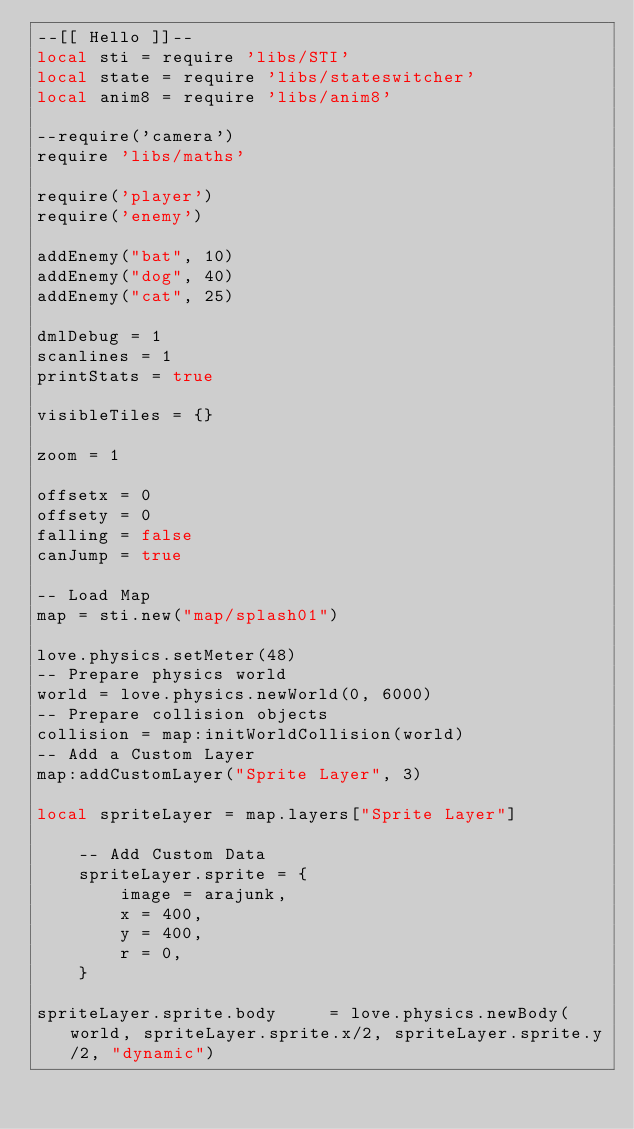Convert code to text. <code><loc_0><loc_0><loc_500><loc_500><_Lua_>--[[ Hello ]]--
local sti = require 'libs/STI'
local state = require 'libs/stateswitcher'
local anim8 = require 'libs/anim8'

--require('camera')
require 'libs/maths'

require('player')
require('enemy')

addEnemy("bat", 10)
addEnemy("dog", 40)
addEnemy("cat", 25)

dmlDebug = 1
scanlines = 1
printStats = true

visibleTiles = {}

zoom = 1

offsetx = 0
offsety = 0
falling = false
canJump = true

-- Load Map
map = sti.new("map/splash01")

love.physics.setMeter(48)
-- Prepare physics world
world = love.physics.newWorld(0, 6000)
-- Prepare collision objects
collision = map:initWorldCollision(world)
-- Add a Custom Layer
map:addCustomLayer("Sprite Layer", 3)

local spriteLayer = map.layers["Sprite Layer"]

	-- Add Custom Data
	spriteLayer.sprite = {
		image = arajunk,
		x = 400,
		y = 400,
		r = 0,
	}
	
spriteLayer.sprite.body		= love.physics.newBody(world, spriteLayer.sprite.x/2, spriteLayer.sprite.y/2, "dynamic")</code> 